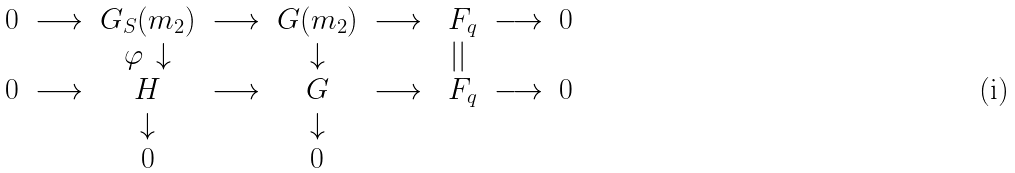<formula> <loc_0><loc_0><loc_500><loc_500>\begin{matrix} 0 & \longrightarrow & G _ { S } ( m _ { 2 } ) & \longrightarrow & G ( m _ { 2 } ) & \longrightarrow & \ F _ { q } & \longrightarrow & 0 \\ & & \varphi \, \downarrow & & \downarrow & & | | & & \\ 0 & \longrightarrow & H & \longrightarrow & G & \longrightarrow & \ F _ { q } & \longrightarrow & 0 \\ & & \downarrow & & \downarrow & & & & \\ & & 0 & & 0 & & & & \end{matrix}</formula> 